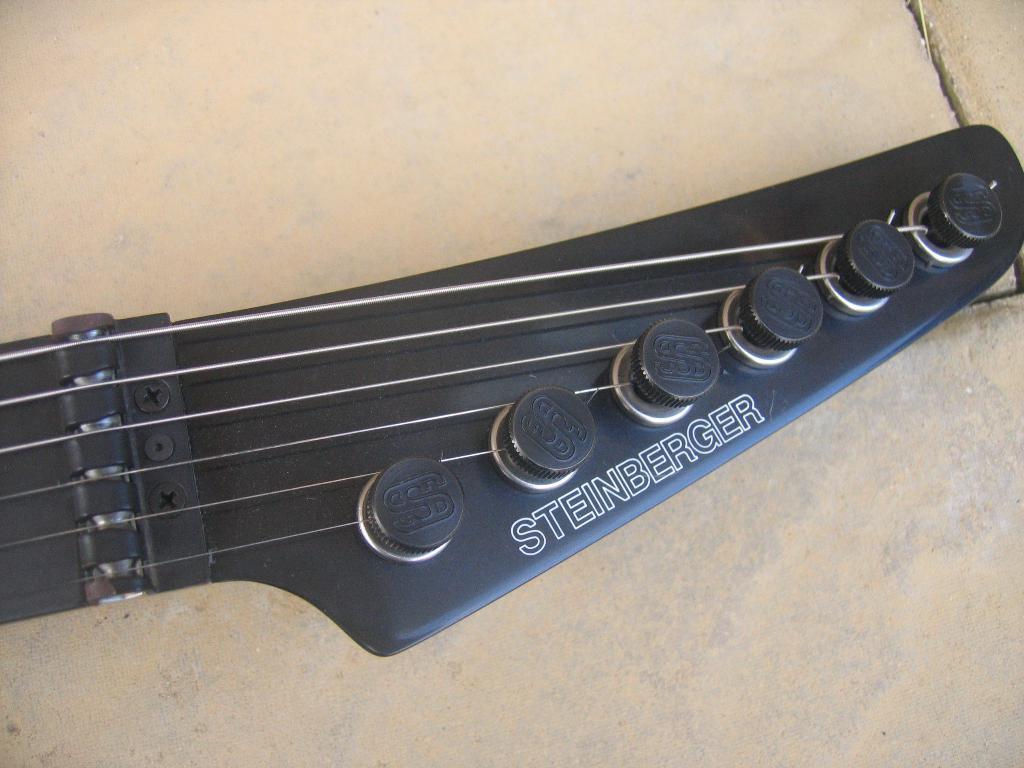Please provide a concise description of this image. There is a black color guitar, which is having six strings on the floor. 